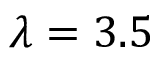Convert formula to latex. <formula><loc_0><loc_0><loc_500><loc_500>\lambda = 3 . 5</formula> 